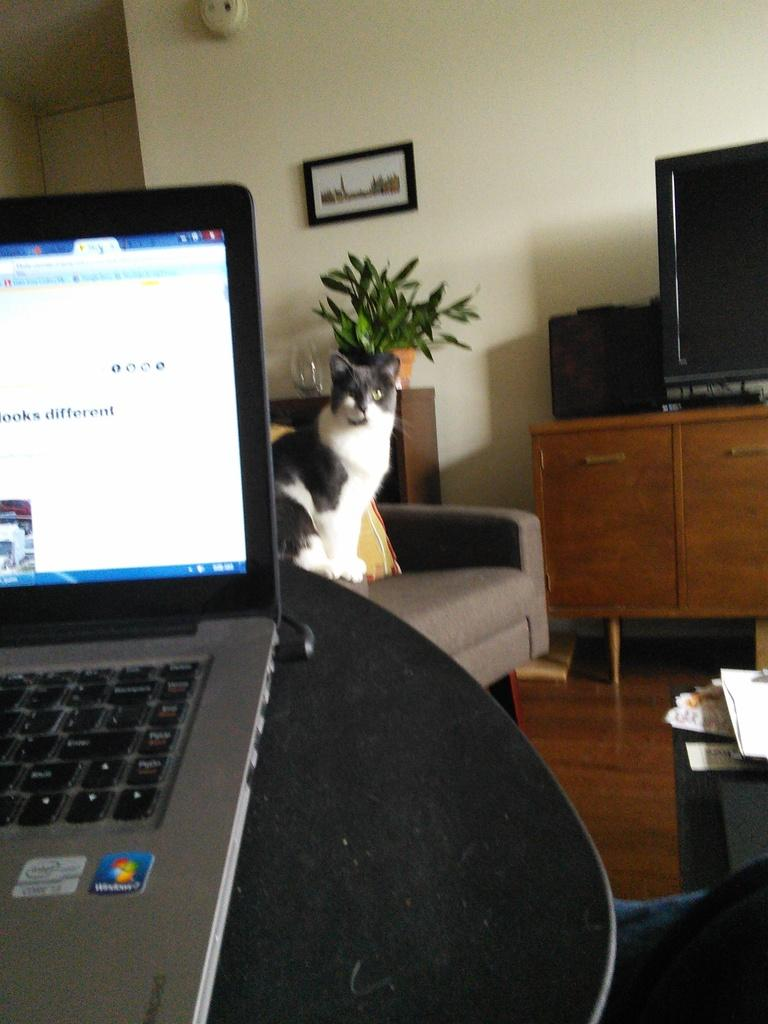What animal can be seen in the image? There is a cat in the image. Where is the cat located? The cat is sitting on a chair. What electronic device is present in the image? There is a laptop on a table in the image. What decorative item is hanging on the wall in the image? There is a photo frame on the wall in the image. How many eggs are in the nest that is visible in the image? There is no nest or eggs present in the image; it features a cat sitting on a chair, a laptop on a table, and a photo frame on the wall. 